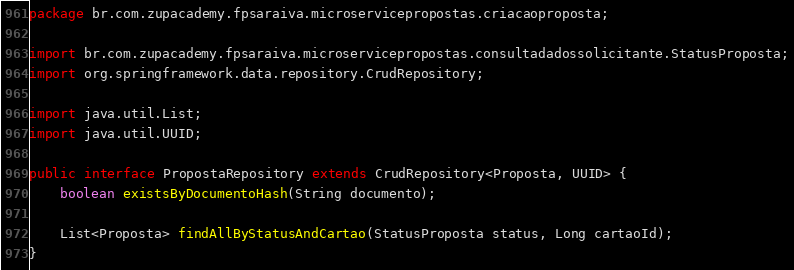Convert code to text. <code><loc_0><loc_0><loc_500><loc_500><_Java_>package br.com.zupacademy.fpsaraiva.microservicepropostas.criacaoproposta;

import br.com.zupacademy.fpsaraiva.microservicepropostas.consultadadossolicitante.StatusProposta;
import org.springframework.data.repository.CrudRepository;

import java.util.List;
import java.util.UUID;

public interface PropostaRepository extends CrudRepository<Proposta, UUID> {
    boolean existsByDocumentoHash(String documento);

    List<Proposta> findAllByStatusAndCartao(StatusProposta status, Long cartaoId);
}
</code> 